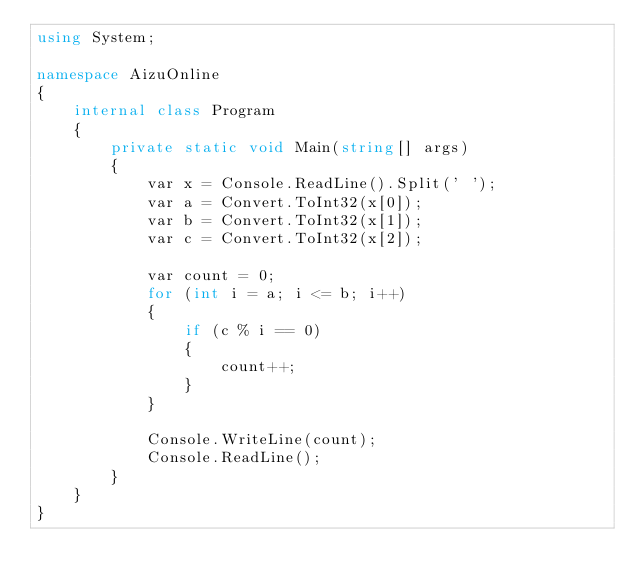Convert code to text. <code><loc_0><loc_0><loc_500><loc_500><_C#_>using System;

namespace AizuOnline
{
    internal class Program
    {
        private static void Main(string[] args)
        {
            var x = Console.ReadLine().Split(' ');
            var a = Convert.ToInt32(x[0]);
            var b = Convert.ToInt32(x[1]);
            var c = Convert.ToInt32(x[2]);

            var count = 0;
            for (int i = a; i <= b; i++)
            {
                if (c % i == 0)
                {
                    count++;
                }
            }

            Console.WriteLine(count);
            Console.ReadLine();
        }
    }
}</code> 